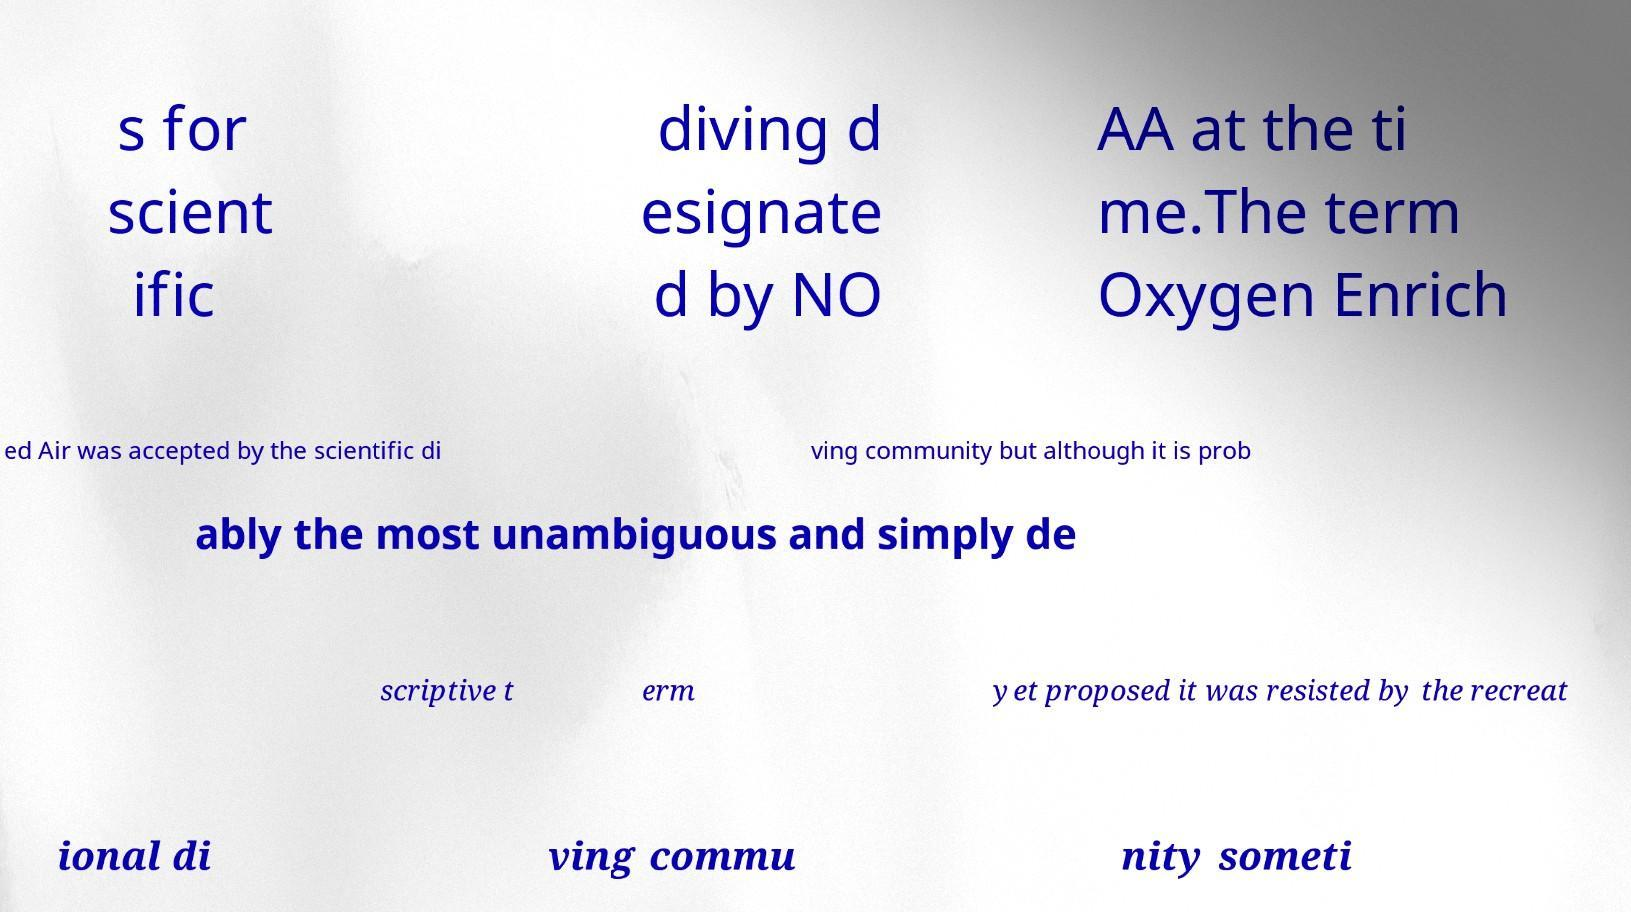Please identify and transcribe the text found in this image. s for scient ific diving d esignate d by NO AA at the ti me.The term Oxygen Enrich ed Air was accepted by the scientific di ving community but although it is prob ably the most unambiguous and simply de scriptive t erm yet proposed it was resisted by the recreat ional di ving commu nity someti 